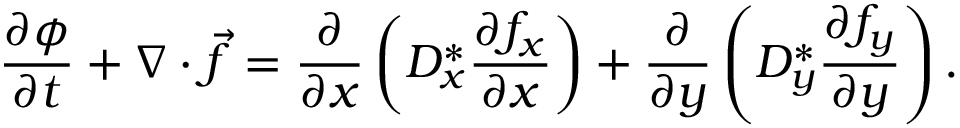<formula> <loc_0><loc_0><loc_500><loc_500>\frac { \partial \phi } { \partial t } + \nabla \cdot \vec { f } = \frac { \partial } { \partial x } \left ( D _ { x } ^ { \ast } \frac { \partial f _ { x } } { \partial x } \right ) + \frac { \partial } { \partial y } \left ( D _ { y } ^ { \ast } \frac { \partial f _ { y } } { \partial y } \right ) .</formula> 